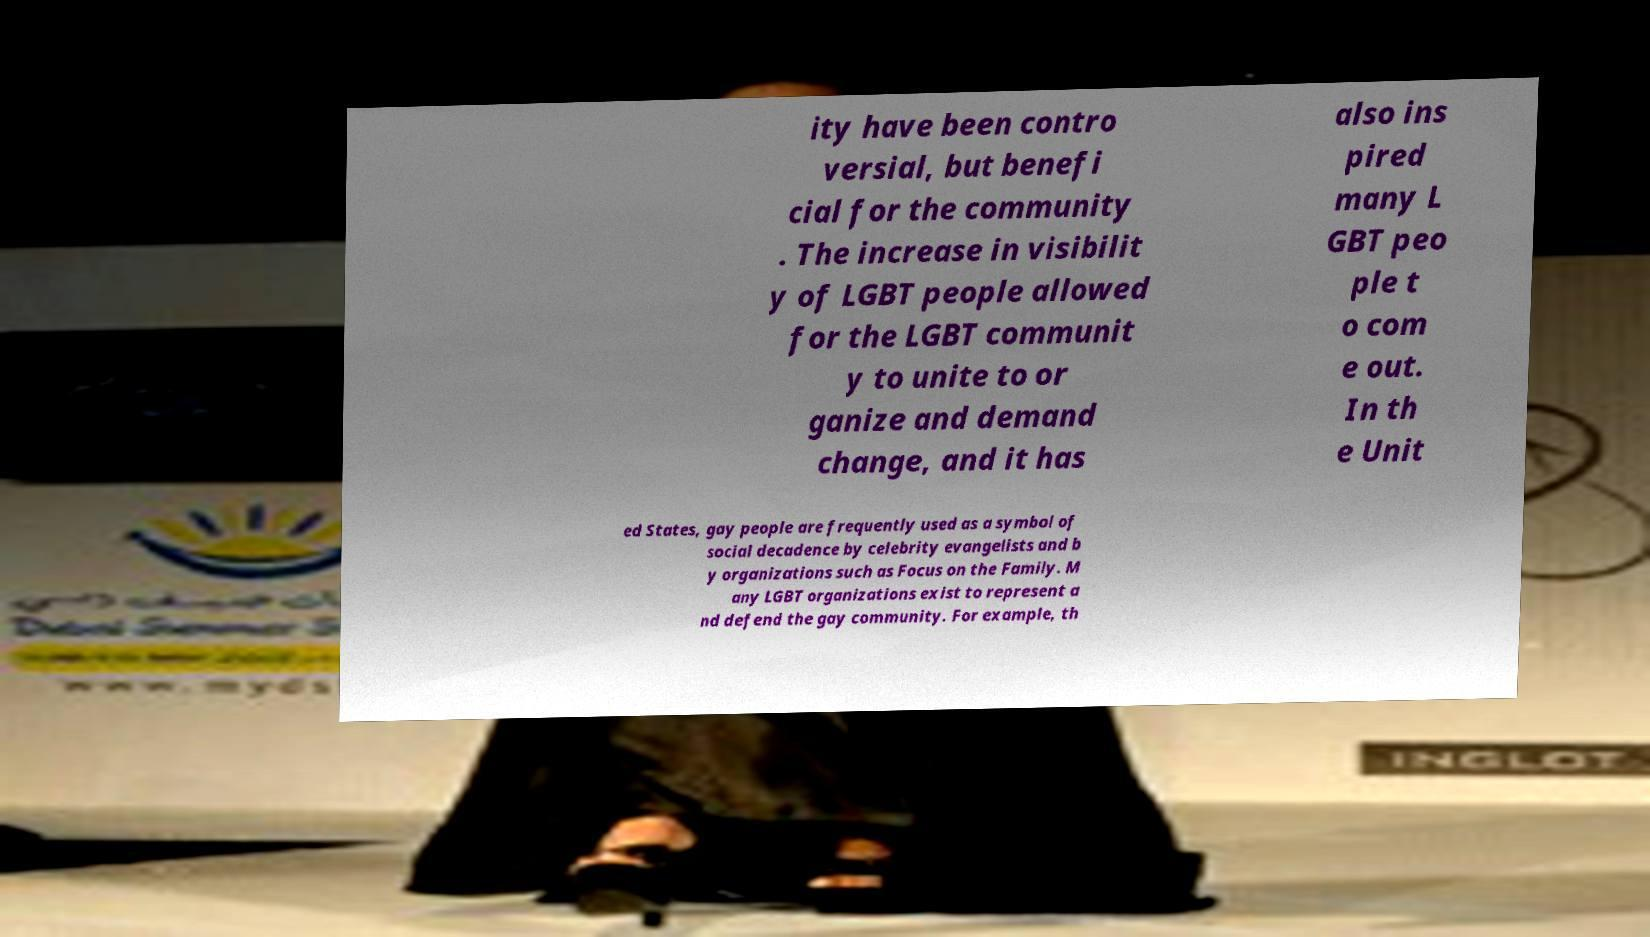Could you extract and type out the text from this image? ity have been contro versial, but benefi cial for the community . The increase in visibilit y of LGBT people allowed for the LGBT communit y to unite to or ganize and demand change, and it has also ins pired many L GBT peo ple t o com e out. In th e Unit ed States, gay people are frequently used as a symbol of social decadence by celebrity evangelists and b y organizations such as Focus on the Family. M any LGBT organizations exist to represent a nd defend the gay community. For example, th 